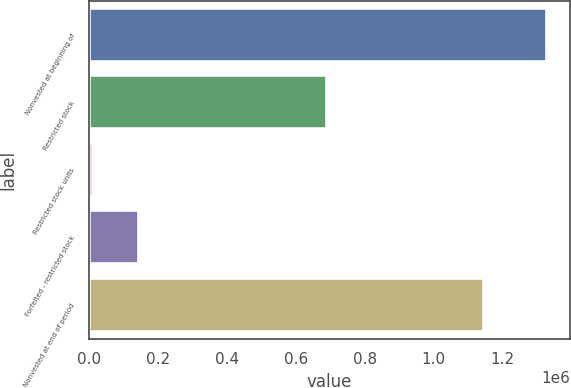Convert chart to OTSL. <chart><loc_0><loc_0><loc_500><loc_500><bar_chart><fcel>Nonvested at beginning of<fcel>Restricted stock<fcel>Restricted stock units<fcel>Forfeited - restricted stock<fcel>Nonvested at end of period<nl><fcel>1.32863e+06<fcel>691052<fcel>11970<fcel>143636<fcel>1.14512e+06<nl></chart> 